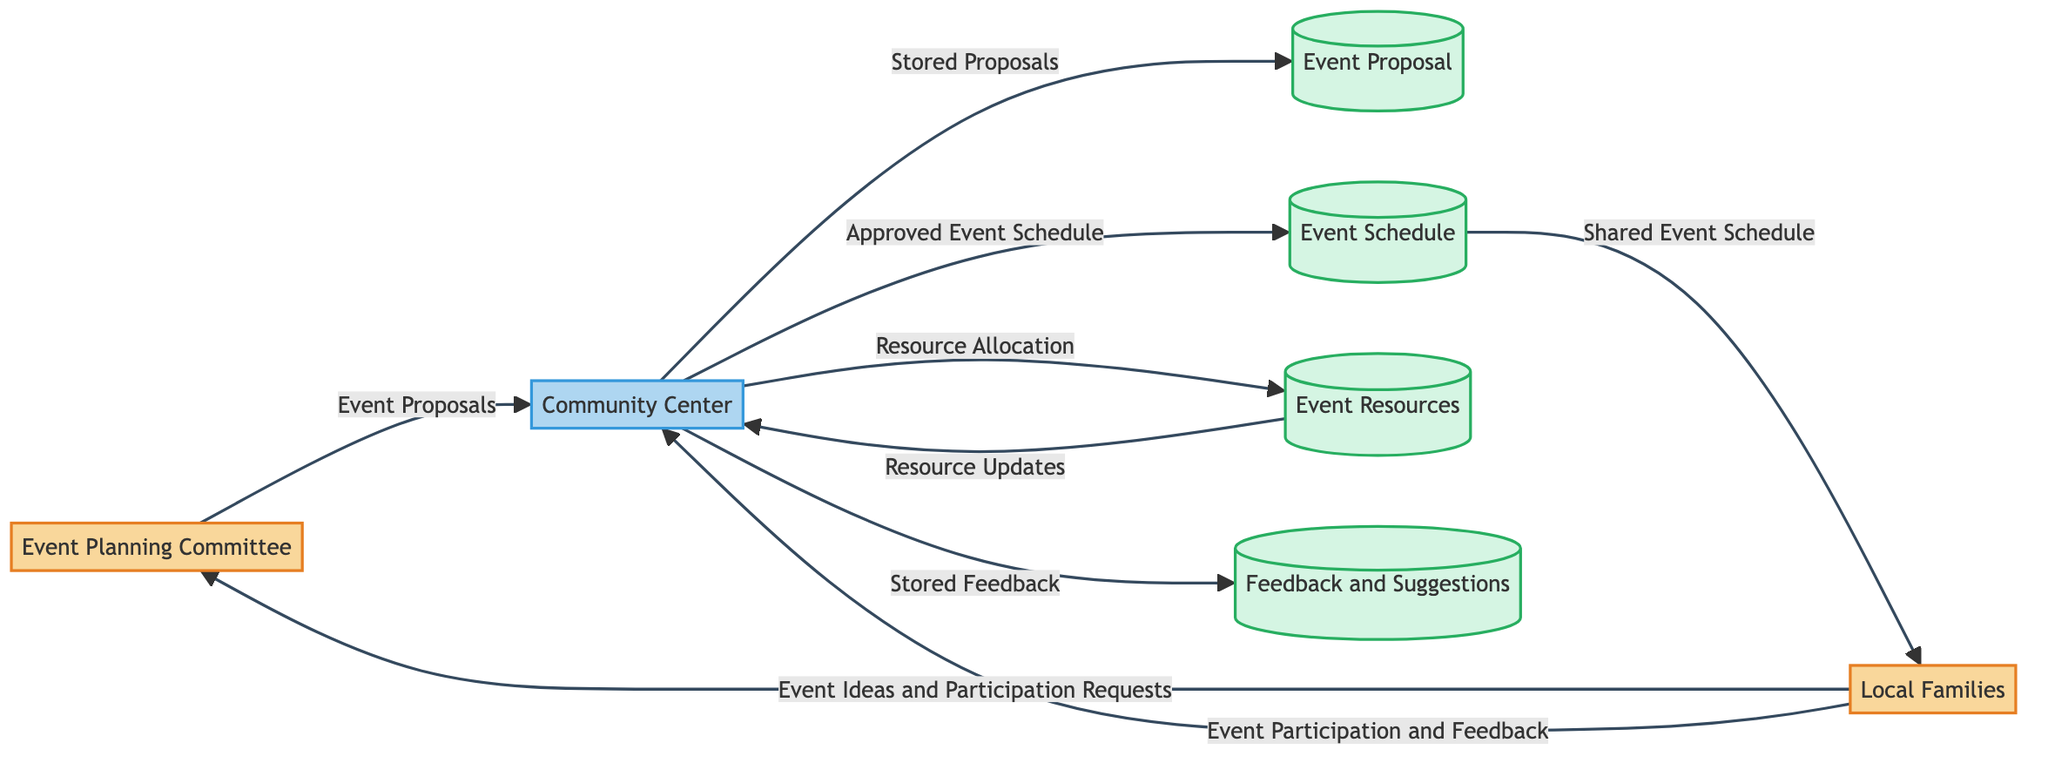What is the central location for events and activities? The diagram indicates that the "Community Center" acts as the central location for events and activities, facilitating communication and resources between various entities.
Answer: Community Center How many data stores are present in the diagram? Upon reviewing the diagram, there are four data stores labeled as "Event Proposal," "Event Schedule," "Event Resources," and "Feedback and Suggestions," totaling four data stores.
Answer: Four Who submits event ideas and participation requests to the Event Planning Committee? The diagram shows that "Local Families" are responsible for submitting event ideas and participation requests, establishing a connection with the Event Planning Committee.
Answer: Local Families What does the Event Planning Committee send to the Community Center? According to the diagram, the Event Planning Committee sends "Event Proposals" to the Community Center as part of the event planning process.
Answer: Event Proposals What type of feedback is collected and stored by the Community Center? The diagram indicates that the "Community Center" collects and stores "Feedback and Suggestions" from community members regarding planned and past events.
Answer: Feedback and Suggestions What information do Local Families receive from the Event Schedule? The diagram clarifies that Local Families receive a "Shared Event Schedule" from the Event Schedule data store, allowing them to stay informed about upcoming events.
Answer: Shared Event Schedule Which external entities communicate with the Community Center? The diagram indicates that both "Local Families" and the "Event Planning Committee" communicate with the Community Center, exchanging various information related to event planning.
Answer: Local Families, Event Planning Committee What types of resources are managed by the Community Center? The diagram specifies that the Community Center manages "Event Resources," which include an inventory of items like tables, chairs, and sound equipment available for events.
Answer: Event Resources Which data store does the Community Center send approved events to? The diagram shows that the Community Center sends approved events to the "Event Schedule" data store, where the list and timeline of upcoming events are maintained.
Answer: Event Schedule 